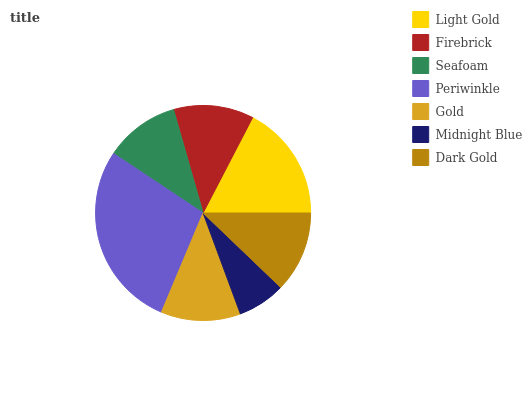Is Midnight Blue the minimum?
Answer yes or no. Yes. Is Periwinkle the maximum?
Answer yes or no. Yes. Is Firebrick the minimum?
Answer yes or no. No. Is Firebrick the maximum?
Answer yes or no. No. Is Light Gold greater than Firebrick?
Answer yes or no. Yes. Is Firebrick less than Light Gold?
Answer yes or no. Yes. Is Firebrick greater than Light Gold?
Answer yes or no. No. Is Light Gold less than Firebrick?
Answer yes or no. No. Is Firebrick the high median?
Answer yes or no. Yes. Is Firebrick the low median?
Answer yes or no. Yes. Is Seafoam the high median?
Answer yes or no. No. Is Gold the low median?
Answer yes or no. No. 